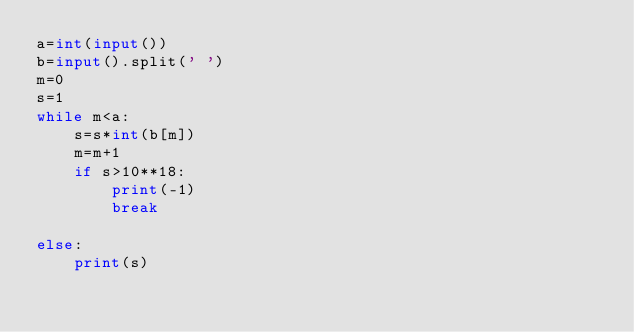Convert code to text. <code><loc_0><loc_0><loc_500><loc_500><_Python_>a=int(input())
b=input().split(' ')
m=0
s=1
while m<a:
    s=s*int(b[m])
    m=m+1
    if s>10**18:
        print(-1)
        break

else:
    print(s)</code> 